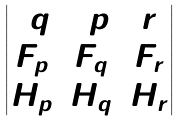<formula> <loc_0><loc_0><loc_500><loc_500>\begin{vmatrix} 2 q & 2 p & r \\ F _ { p } & F _ { q } & F _ { r } \\ H _ { p } & H _ { q } & H _ { r } \end{vmatrix}</formula> 